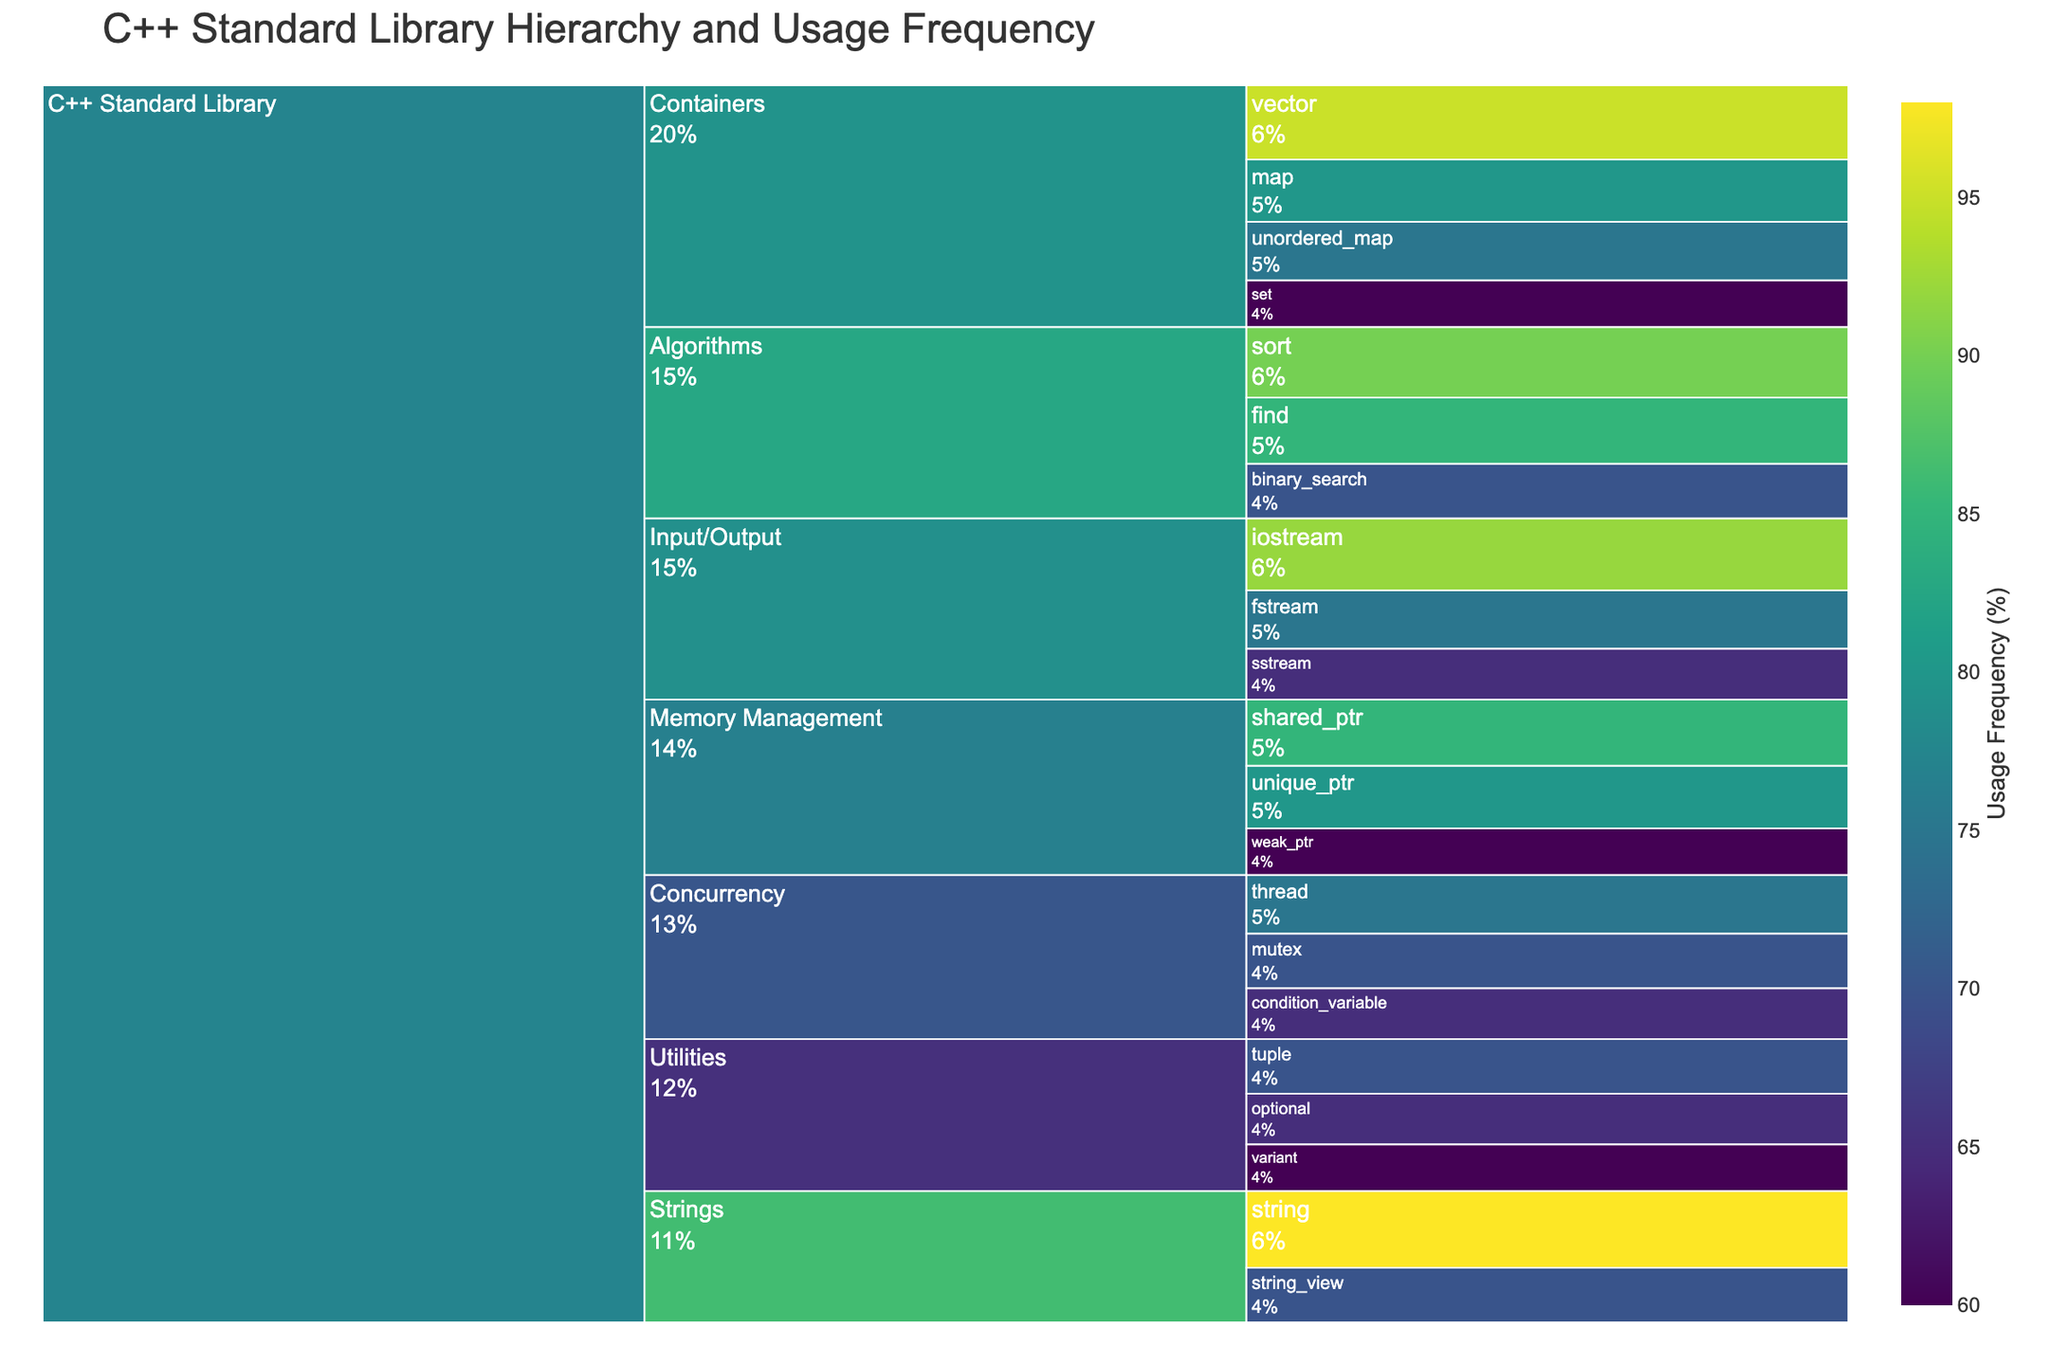what is the title of the figure? The title of the figure appears prominently at the top and reads 'C++ Standard Library Hierarchy and Usage Frequency'.
Answer: C++ Standard Library Hierarchy and Usage Frequency What is the usage frequency of the 'string' subcategory? The subcategory 'string' is found under the 'Strings' category, with a usage frequency indicated by the number next to its label. The plot shows it as 'string<br>98%'.
Answer: 98% Which category has the highest overall usage frequency when considering all its subcategories' frequencies combined? By examining each category's subcategories and summing their usage frequencies: Containers (310), Algorithms (245), Input/Output (232), Strings (168), Memory Management (225), Concurrency (210), Utilities (195). The 'Containers' category has the highest combined usage frequency.
Answer: Containers How does the usage frequency of 'shared_ptr' compare to 'unique_ptr'? Both subcategories are under 'Memory Management'. The usage frequency for 'shared_ptr' is 85%, and for 'unique_ptr' is 80%, making 'shared_ptr' higher.
Answer: shared_ptr is higher Which subcategory within 'Concurrency' has the lowest usage frequency? Under 'Concurrency', the subcategories are 'thread' (75%), 'mutex' (70%), and 'condition_variable' (65%). 'condition_variable' has the lowest frequency.
Answer: condition_variable What is the combined usage frequency for all the subcategories in 'Input/Output'? Add the usage frequencies of 'iostream' (92%), 'fstream' (75%), and 'sstream' (65%) together: 92 + 75 + 65 = 232.
Answer: 232% Identify the subcategory with the second highest usage frequency across the entire C++ Standard Library Hierarchy. The subcategory 'string' in 'Strings' has the highest frequency (98%). The second highest is 'vector' in 'Containers' with 95%.
Answer: vector Which category has equal usage frequencies for two of its subcategories? By inspecting the categories and their subcategories, 'Utilities' has both 'variant' and 'optional' with the same usage frequency of 60%.
Answer: Utilities What is the average usage frequency of the 'Memory Management' category's subcategories? Calculate the average usage frequency for 'shared_ptr' (85), 'unique_ptr' (80), and 'weak_ptr' (60): (85 + 80 + 60) / 3 = 75.
Answer: 75 If the 'Memory Management' subcategory frequencies were combined, how would they compare to the sum of frequencies in 'Concurrency'? Sum frequencies for 'Memory Management': 85 + 80 + 60 = 225. Sum frequencies for 'Concurrency': 75 + 70 + 65 = 210. Memory Management has a higher frequency.
Answer: Memory Management is higher 